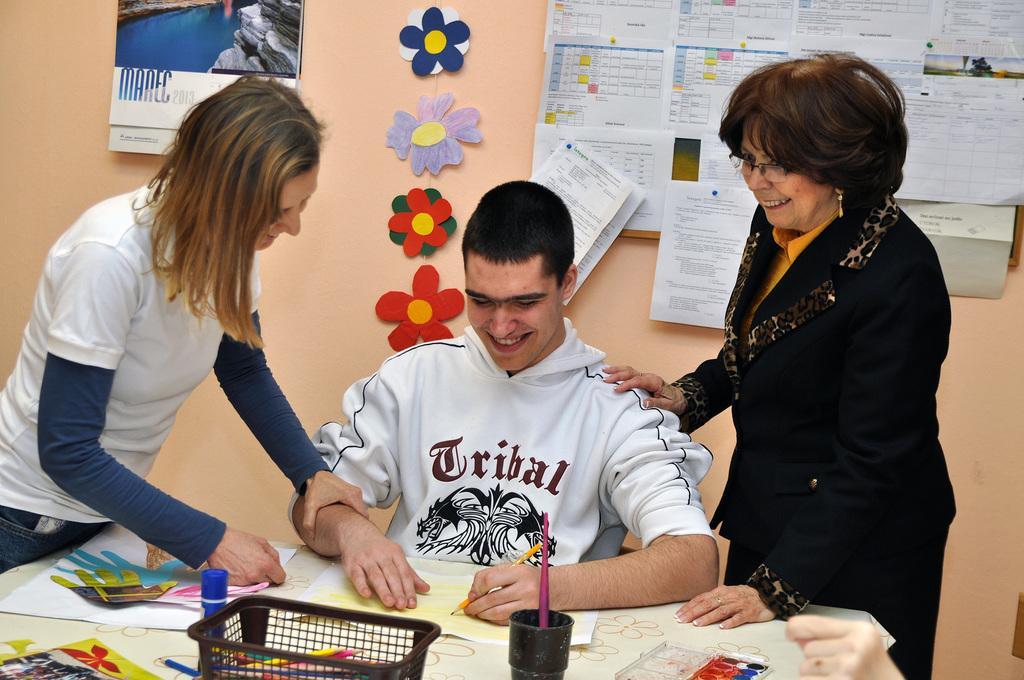Could you give a brief overview of what you see in this image? In this image I can see three people with different color dresses. In-front of these people I can see the table. On the table I can see the papers, pens cup, basket with some objects and colors. In the background I can see the papers, calendar and decorative objects to the wall. 